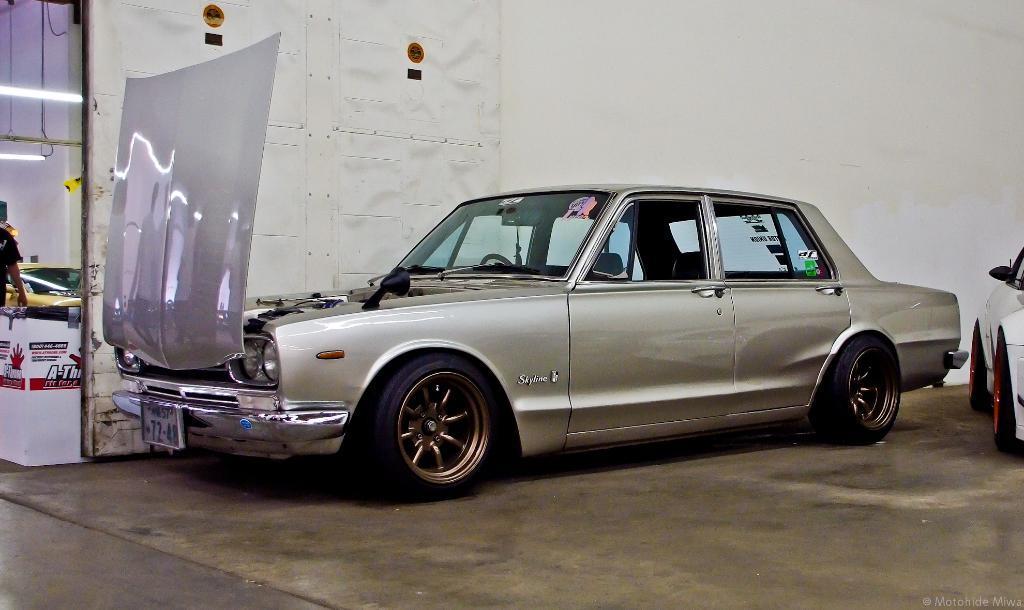Can you describe this image briefly? In this picture there is a silver car is parked in the shed. In the front we can see bonnet door and in the background there is a white color wall. 